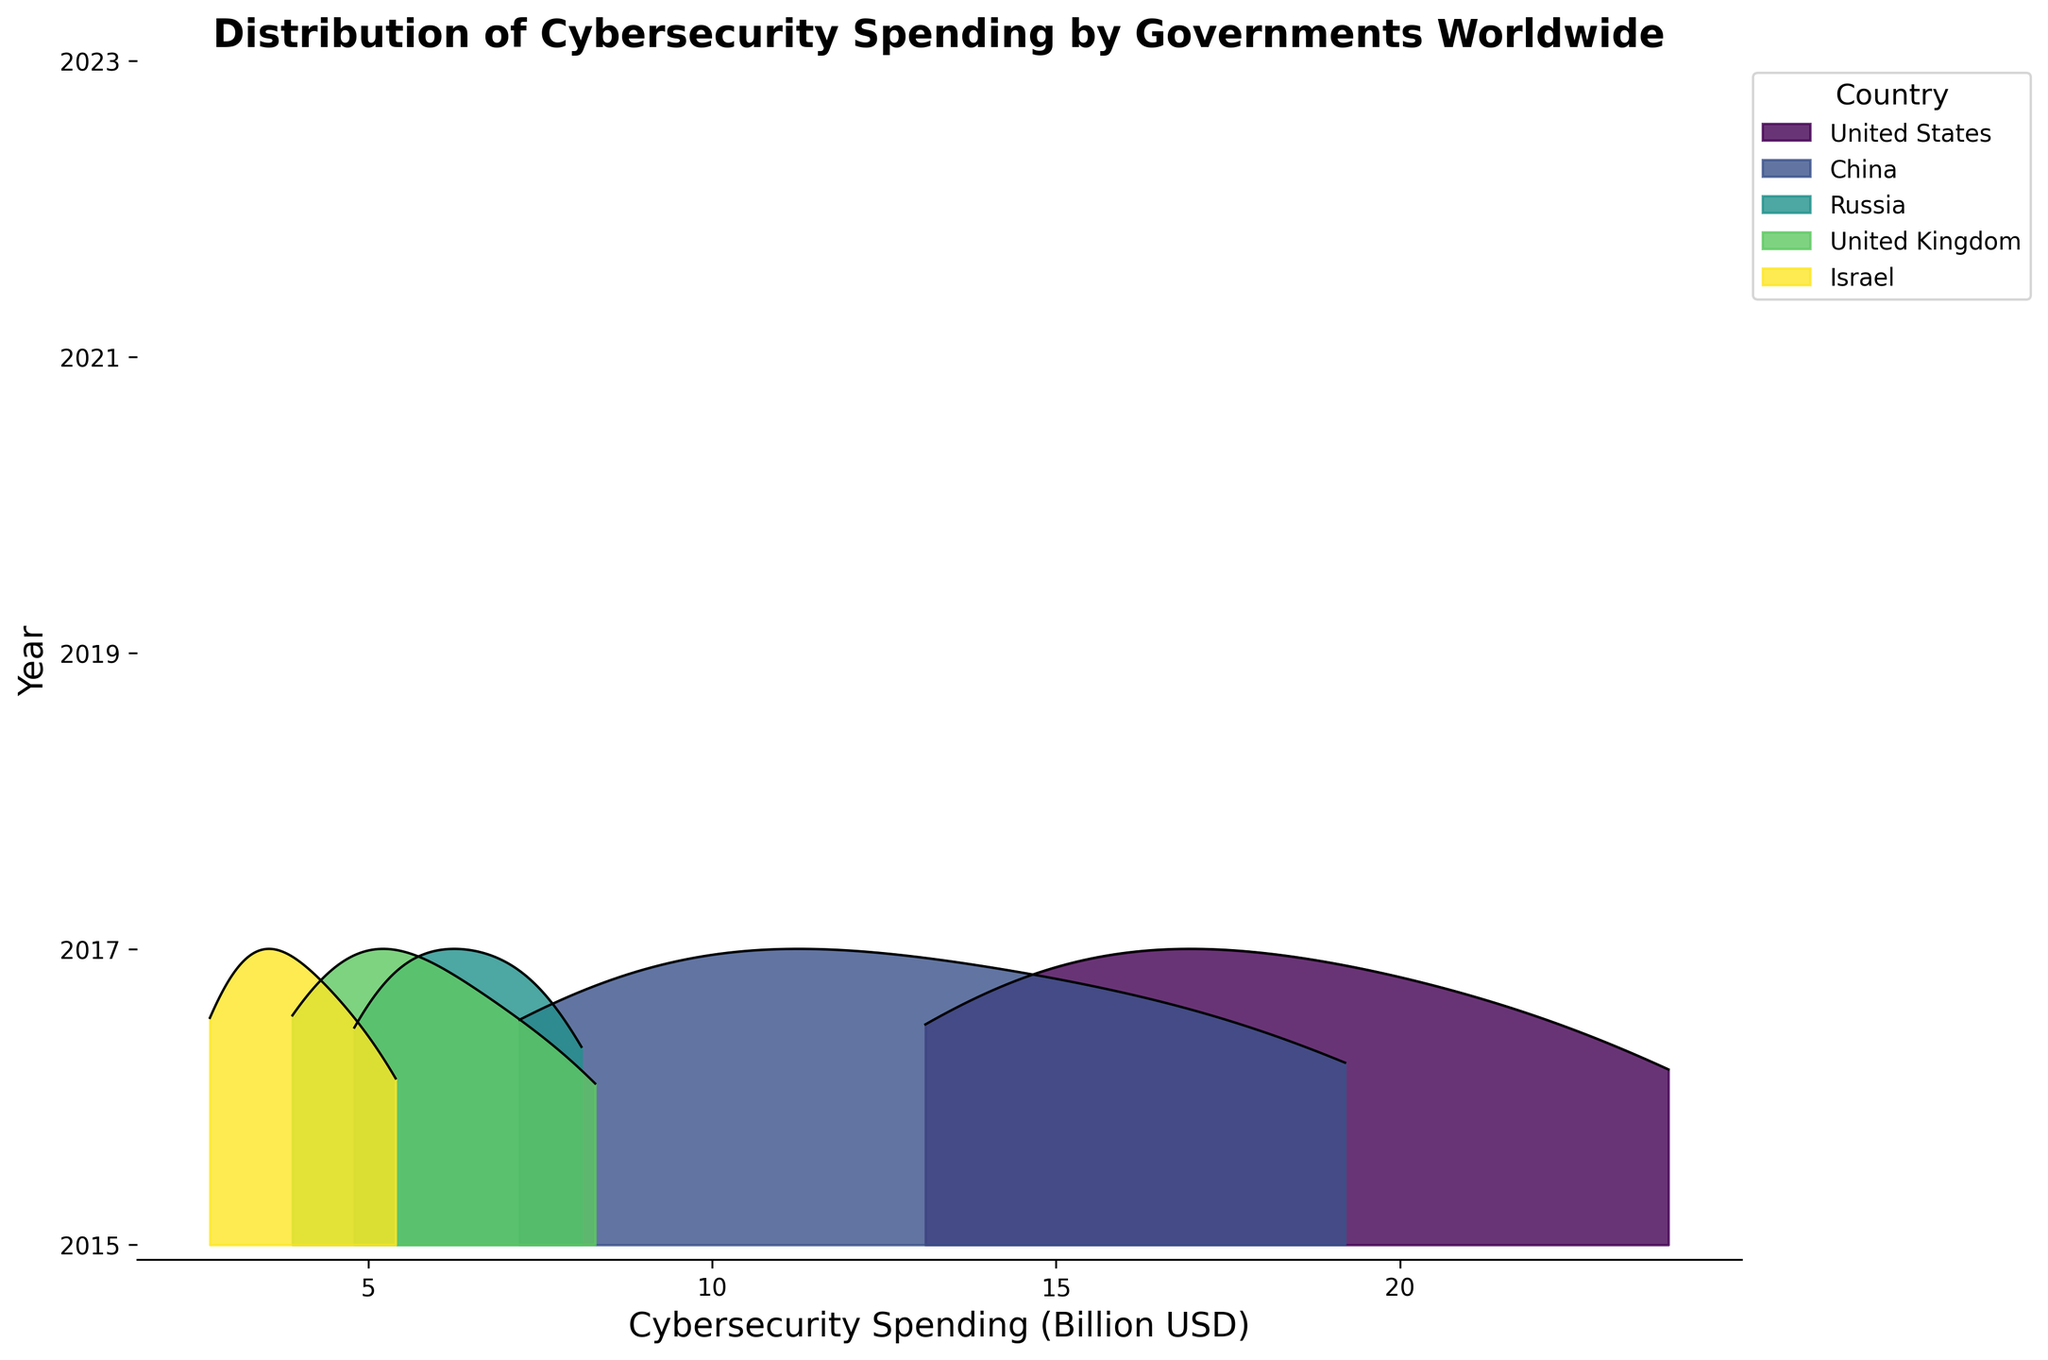Which country has the highest cybersecurity spending in 2023? The country with the highest KDE peak in 2023 indicates the highest spending. The United States shows the highest peak for 2023.
Answer: United States How does the cybersecurity spending trend for China change over the years? By observing the peaks for China in each year: The spending for China increases consistently from 2015 to 2023.
Answer: Increases What's the difference in the United Kingdom's cybersecurity spending between 2015 and 2023? Locate the KDE peaks for the United Kingdom in 2015 and 2023, then subtract the 2015 spending from the 2023 spending: 8.3 (2023) - 3.9 (2015) = 4.4.
Answer: 4.4 Which countries show a marked increase in cybersecurity spending from 2015 to 2023? Compare the KDE peaks for each country across the years. The United States, China, and the United Kingdom show significant increases.
Answer: United States, China, United Kingdom Which country had the least cybersecurity spending in 2021? Look for the country with the lowest KDE peak in 2021. Israel has the lowest peak in 2021.
Answer: Israel How does the distribution pattern of cybersecurity spending in Israel differ between 2015 and 2023? Compare the KDE shapes and peaks for Israel in 2015 and 2023: In 2015, the peak is lower, and in 2023, it is higher, indicating an increase in spending.
Answer: Increased spending Which two countries had almost similar cybersecurity spending in 2023? By comparing KDE peaks for different countries in 2023, the United Kingdom and Russia have close peaks around 8.1-8.3.
Answer: United Kingdom, Russia What is the general trend of cybersecurity spending worldwide from 2015 to 2023? Observing the overall KDE shapes and peaks across all countries, there is a clear upward trend in the peaks, showing increased spending globally over the years.
Answer: Upward trend Which year shows the largest increase in cybersecurity spending for the United States? Compare the KDE peak heights for the United States between consecutive years and find the largest difference. The largest increase is between 2019 and 2021: 20.5 (2021) - 17.8 (2019) = 2.7.
Answer: 2019 to 2021 